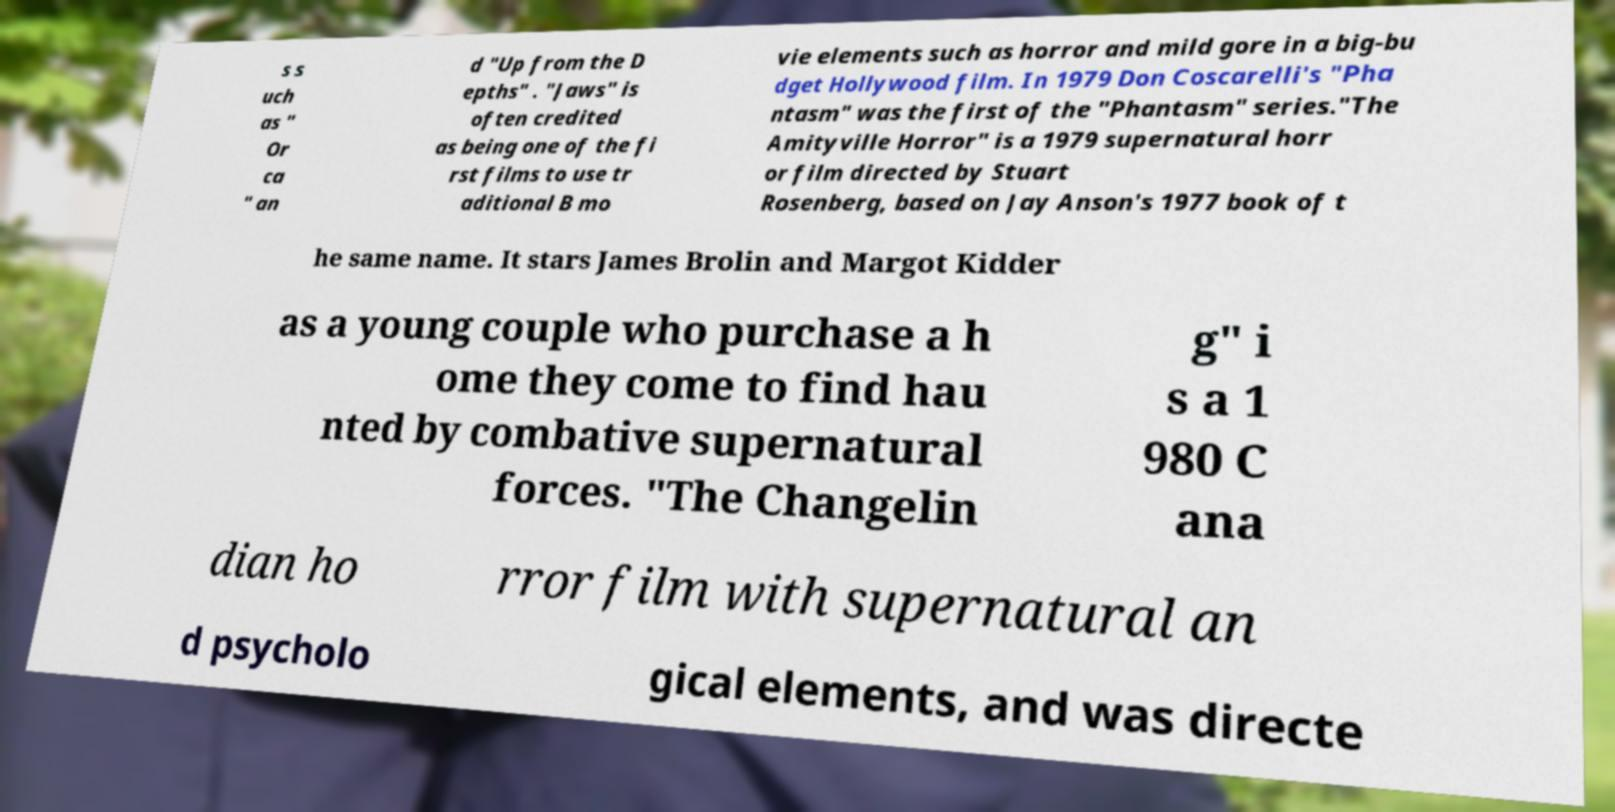There's text embedded in this image that I need extracted. Can you transcribe it verbatim? s s uch as " Or ca " an d "Up from the D epths" . "Jaws" is often credited as being one of the fi rst films to use tr aditional B mo vie elements such as horror and mild gore in a big-bu dget Hollywood film. In 1979 Don Coscarelli's "Pha ntasm" was the first of the "Phantasm" series."The Amityville Horror" is a 1979 supernatural horr or film directed by Stuart Rosenberg, based on Jay Anson's 1977 book of t he same name. It stars James Brolin and Margot Kidder as a young couple who purchase a h ome they come to find hau nted by combative supernatural forces. "The Changelin g" i s a 1 980 C ana dian ho rror film with supernatural an d psycholo gical elements, and was directe 